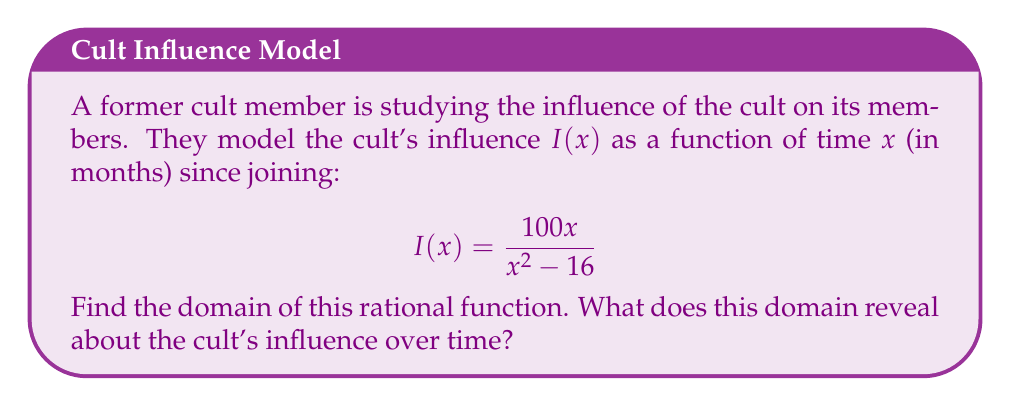Could you help me with this problem? To find the domain of the rational function, we need to determine all values of $x$ for which the function is defined. The steps are as follows:

1) A rational function is undefined when its denominator equals zero. So, we need to solve:
   $$x^2 - 16 = 0$$

2) Factor the equation:
   $$(x+4)(x-4) = 0$$

3) Solve for x:
   $x = -4$ or $x = 4$

4) The domain of the function includes all real numbers except these two values.

5) Interpretation: The function is undefined at $x = 4$ and $x = -4$. Since time cannot be negative in this context, we can disregard the negative solution.

6) The domain can be expressed in interval notation as: $(-\infty, 4) \cup (4, \infty)$

7) In the context of cult influence, this means:
   - The model is valid for any time period except exactly 4 months after joining.
   - There's a "critical point" at 4 months where the influence model breaks down, possibly indicating a significant event or change in the cult's influence tactics.
Answer: $(-\infty, 4) \cup (4, \infty)$ 